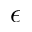Convert formula to latex. <formula><loc_0><loc_0><loc_500><loc_500>\epsilon</formula> 